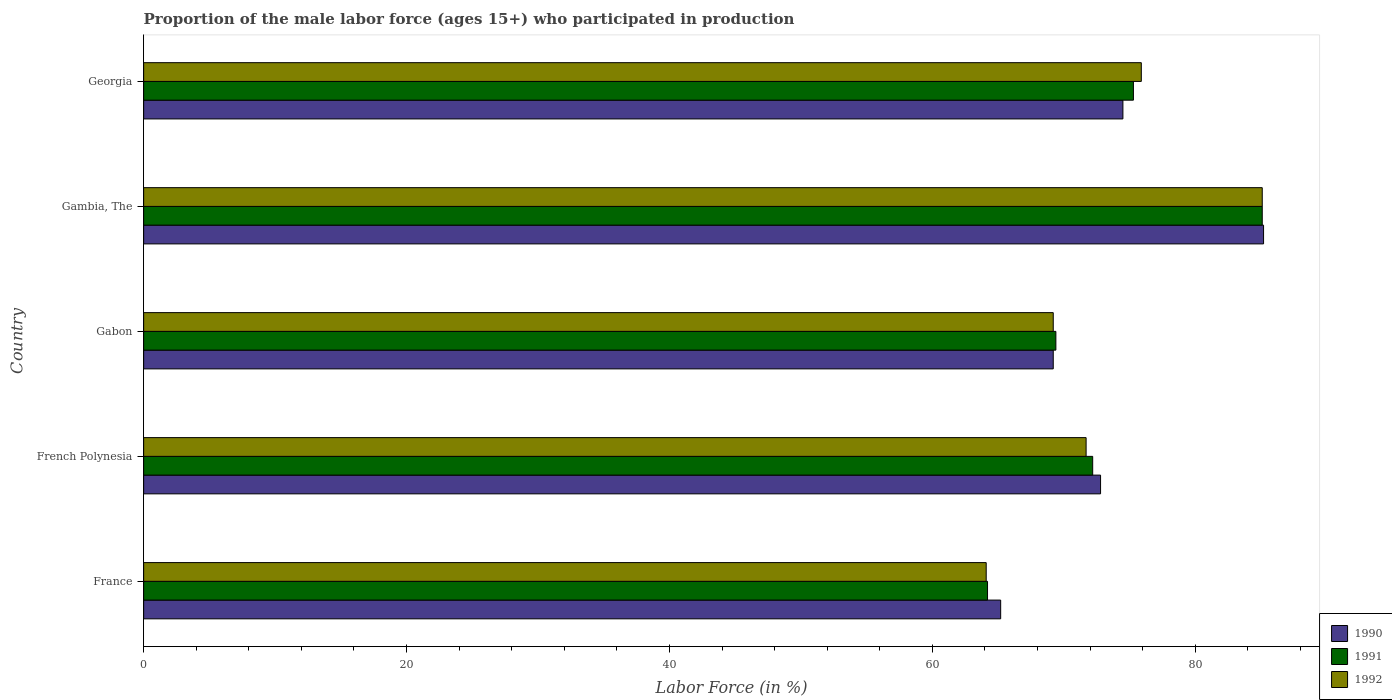Are the number of bars on each tick of the Y-axis equal?
Your answer should be compact. Yes. What is the label of the 5th group of bars from the top?
Offer a terse response. France. What is the proportion of the male labor force who participated in production in 1991 in French Polynesia?
Offer a terse response. 72.2. Across all countries, what is the maximum proportion of the male labor force who participated in production in 1990?
Your response must be concise. 85.2. Across all countries, what is the minimum proportion of the male labor force who participated in production in 1991?
Offer a very short reply. 64.2. In which country was the proportion of the male labor force who participated in production in 1992 maximum?
Provide a succinct answer. Gambia, The. What is the total proportion of the male labor force who participated in production in 1990 in the graph?
Provide a succinct answer. 366.9. What is the difference between the proportion of the male labor force who participated in production in 1992 in Gambia, The and that in Georgia?
Offer a terse response. 9.2. What is the difference between the proportion of the male labor force who participated in production in 1992 in Gambia, The and the proportion of the male labor force who participated in production in 1991 in French Polynesia?
Your answer should be very brief. 12.9. What is the average proportion of the male labor force who participated in production in 1990 per country?
Ensure brevity in your answer.  73.38. What is the difference between the proportion of the male labor force who participated in production in 1992 and proportion of the male labor force who participated in production in 1990 in French Polynesia?
Offer a very short reply. -1.1. What is the ratio of the proportion of the male labor force who participated in production in 1992 in Gambia, The to that in Georgia?
Provide a short and direct response. 1.12. Is the difference between the proportion of the male labor force who participated in production in 1992 in French Polynesia and Gambia, The greater than the difference between the proportion of the male labor force who participated in production in 1990 in French Polynesia and Gambia, The?
Your response must be concise. No. What is the difference between the highest and the second highest proportion of the male labor force who participated in production in 1990?
Offer a terse response. 10.7. What is the difference between the highest and the lowest proportion of the male labor force who participated in production in 1991?
Make the answer very short. 20.9. What does the 3rd bar from the top in Gambia, The represents?
Ensure brevity in your answer.  1990. What does the 1st bar from the bottom in Georgia represents?
Provide a succinct answer. 1990. Are all the bars in the graph horizontal?
Offer a very short reply. Yes. Does the graph contain any zero values?
Offer a very short reply. No. How many legend labels are there?
Provide a succinct answer. 3. What is the title of the graph?
Provide a succinct answer. Proportion of the male labor force (ages 15+) who participated in production. Does "2002" appear as one of the legend labels in the graph?
Offer a terse response. No. What is the label or title of the Y-axis?
Offer a very short reply. Country. What is the Labor Force (in %) of 1990 in France?
Offer a terse response. 65.2. What is the Labor Force (in %) of 1991 in France?
Ensure brevity in your answer.  64.2. What is the Labor Force (in %) of 1992 in France?
Give a very brief answer. 64.1. What is the Labor Force (in %) in 1990 in French Polynesia?
Provide a succinct answer. 72.8. What is the Labor Force (in %) of 1991 in French Polynesia?
Provide a short and direct response. 72.2. What is the Labor Force (in %) of 1992 in French Polynesia?
Provide a succinct answer. 71.7. What is the Labor Force (in %) of 1990 in Gabon?
Your response must be concise. 69.2. What is the Labor Force (in %) in 1991 in Gabon?
Keep it short and to the point. 69.4. What is the Labor Force (in %) of 1992 in Gabon?
Ensure brevity in your answer.  69.2. What is the Labor Force (in %) of 1990 in Gambia, The?
Your answer should be very brief. 85.2. What is the Labor Force (in %) of 1991 in Gambia, The?
Provide a succinct answer. 85.1. What is the Labor Force (in %) in 1992 in Gambia, The?
Keep it short and to the point. 85.1. What is the Labor Force (in %) in 1990 in Georgia?
Provide a succinct answer. 74.5. What is the Labor Force (in %) in 1991 in Georgia?
Offer a very short reply. 75.3. What is the Labor Force (in %) of 1992 in Georgia?
Offer a very short reply. 75.9. Across all countries, what is the maximum Labor Force (in %) in 1990?
Provide a short and direct response. 85.2. Across all countries, what is the maximum Labor Force (in %) of 1991?
Your answer should be very brief. 85.1. Across all countries, what is the maximum Labor Force (in %) of 1992?
Offer a very short reply. 85.1. Across all countries, what is the minimum Labor Force (in %) of 1990?
Your answer should be very brief. 65.2. Across all countries, what is the minimum Labor Force (in %) in 1991?
Your response must be concise. 64.2. Across all countries, what is the minimum Labor Force (in %) of 1992?
Keep it short and to the point. 64.1. What is the total Labor Force (in %) in 1990 in the graph?
Offer a very short reply. 366.9. What is the total Labor Force (in %) of 1991 in the graph?
Your response must be concise. 366.2. What is the total Labor Force (in %) in 1992 in the graph?
Your answer should be very brief. 366. What is the difference between the Labor Force (in %) of 1990 in France and that in French Polynesia?
Offer a very short reply. -7.6. What is the difference between the Labor Force (in %) of 1991 in France and that in French Polynesia?
Give a very brief answer. -8. What is the difference between the Labor Force (in %) of 1992 in France and that in French Polynesia?
Your answer should be compact. -7.6. What is the difference between the Labor Force (in %) in 1991 in France and that in Gabon?
Make the answer very short. -5.2. What is the difference between the Labor Force (in %) of 1991 in France and that in Gambia, The?
Offer a terse response. -20.9. What is the difference between the Labor Force (in %) in 1992 in France and that in Gambia, The?
Your answer should be compact. -21. What is the difference between the Labor Force (in %) in 1990 in France and that in Georgia?
Ensure brevity in your answer.  -9.3. What is the difference between the Labor Force (in %) in 1991 in France and that in Georgia?
Offer a very short reply. -11.1. What is the difference between the Labor Force (in %) in 1991 in French Polynesia and that in Gambia, The?
Give a very brief answer. -12.9. What is the difference between the Labor Force (in %) in 1992 in French Polynesia and that in Gambia, The?
Give a very brief answer. -13.4. What is the difference between the Labor Force (in %) in 1992 in French Polynesia and that in Georgia?
Your answer should be very brief. -4.2. What is the difference between the Labor Force (in %) in 1991 in Gabon and that in Gambia, The?
Your response must be concise. -15.7. What is the difference between the Labor Force (in %) of 1992 in Gabon and that in Gambia, The?
Offer a terse response. -15.9. What is the difference between the Labor Force (in %) of 1991 in Gabon and that in Georgia?
Your answer should be very brief. -5.9. What is the difference between the Labor Force (in %) of 1992 in Gabon and that in Georgia?
Your answer should be compact. -6.7. What is the difference between the Labor Force (in %) of 1990 in Gambia, The and that in Georgia?
Provide a succinct answer. 10.7. What is the difference between the Labor Force (in %) in 1991 in Gambia, The and that in Georgia?
Provide a succinct answer. 9.8. What is the difference between the Labor Force (in %) of 1992 in Gambia, The and that in Georgia?
Your response must be concise. 9.2. What is the difference between the Labor Force (in %) of 1990 in France and the Labor Force (in %) of 1991 in French Polynesia?
Provide a succinct answer. -7. What is the difference between the Labor Force (in %) in 1990 in France and the Labor Force (in %) in 1992 in French Polynesia?
Make the answer very short. -6.5. What is the difference between the Labor Force (in %) of 1990 in France and the Labor Force (in %) of 1992 in Gabon?
Give a very brief answer. -4. What is the difference between the Labor Force (in %) in 1990 in France and the Labor Force (in %) in 1991 in Gambia, The?
Offer a terse response. -19.9. What is the difference between the Labor Force (in %) in 1990 in France and the Labor Force (in %) in 1992 in Gambia, The?
Your response must be concise. -19.9. What is the difference between the Labor Force (in %) in 1991 in France and the Labor Force (in %) in 1992 in Gambia, The?
Your response must be concise. -20.9. What is the difference between the Labor Force (in %) of 1990 in France and the Labor Force (in %) of 1992 in Georgia?
Give a very brief answer. -10.7. What is the difference between the Labor Force (in %) in 1991 in France and the Labor Force (in %) in 1992 in Georgia?
Your response must be concise. -11.7. What is the difference between the Labor Force (in %) of 1990 in French Polynesia and the Labor Force (in %) of 1991 in Gabon?
Your answer should be very brief. 3.4. What is the difference between the Labor Force (in %) in 1991 in French Polynesia and the Labor Force (in %) in 1992 in Gambia, The?
Provide a succinct answer. -12.9. What is the difference between the Labor Force (in %) of 1990 in French Polynesia and the Labor Force (in %) of 1991 in Georgia?
Provide a short and direct response. -2.5. What is the difference between the Labor Force (in %) in 1990 in French Polynesia and the Labor Force (in %) in 1992 in Georgia?
Offer a very short reply. -3.1. What is the difference between the Labor Force (in %) in 1991 in French Polynesia and the Labor Force (in %) in 1992 in Georgia?
Provide a short and direct response. -3.7. What is the difference between the Labor Force (in %) in 1990 in Gabon and the Labor Force (in %) in 1991 in Gambia, The?
Your answer should be compact. -15.9. What is the difference between the Labor Force (in %) of 1990 in Gabon and the Labor Force (in %) of 1992 in Gambia, The?
Offer a very short reply. -15.9. What is the difference between the Labor Force (in %) of 1991 in Gabon and the Labor Force (in %) of 1992 in Gambia, The?
Offer a terse response. -15.7. What is the difference between the Labor Force (in %) of 1991 in Gabon and the Labor Force (in %) of 1992 in Georgia?
Provide a short and direct response. -6.5. What is the difference between the Labor Force (in %) of 1990 in Gambia, The and the Labor Force (in %) of 1992 in Georgia?
Keep it short and to the point. 9.3. What is the difference between the Labor Force (in %) in 1991 in Gambia, The and the Labor Force (in %) in 1992 in Georgia?
Your response must be concise. 9.2. What is the average Labor Force (in %) of 1990 per country?
Give a very brief answer. 73.38. What is the average Labor Force (in %) in 1991 per country?
Provide a short and direct response. 73.24. What is the average Labor Force (in %) of 1992 per country?
Your answer should be compact. 73.2. What is the difference between the Labor Force (in %) of 1990 and Labor Force (in %) of 1991 in France?
Your response must be concise. 1. What is the difference between the Labor Force (in %) of 1990 and Labor Force (in %) of 1992 in France?
Make the answer very short. 1.1. What is the difference between the Labor Force (in %) of 1990 and Labor Force (in %) of 1991 in French Polynesia?
Make the answer very short. 0.6. What is the difference between the Labor Force (in %) of 1991 and Labor Force (in %) of 1992 in French Polynesia?
Provide a short and direct response. 0.5. What is the difference between the Labor Force (in %) of 1990 and Labor Force (in %) of 1992 in Gabon?
Provide a short and direct response. 0. What is the difference between the Labor Force (in %) in 1990 and Labor Force (in %) in 1991 in Gambia, The?
Offer a terse response. 0.1. What is the difference between the Labor Force (in %) in 1990 and Labor Force (in %) in 1992 in Gambia, The?
Provide a succinct answer. 0.1. What is the difference between the Labor Force (in %) in 1990 and Labor Force (in %) in 1991 in Georgia?
Make the answer very short. -0.8. What is the ratio of the Labor Force (in %) of 1990 in France to that in French Polynesia?
Offer a terse response. 0.9. What is the ratio of the Labor Force (in %) of 1991 in France to that in French Polynesia?
Ensure brevity in your answer.  0.89. What is the ratio of the Labor Force (in %) in 1992 in France to that in French Polynesia?
Keep it short and to the point. 0.89. What is the ratio of the Labor Force (in %) of 1990 in France to that in Gabon?
Provide a short and direct response. 0.94. What is the ratio of the Labor Force (in %) of 1991 in France to that in Gabon?
Make the answer very short. 0.93. What is the ratio of the Labor Force (in %) of 1992 in France to that in Gabon?
Provide a short and direct response. 0.93. What is the ratio of the Labor Force (in %) in 1990 in France to that in Gambia, The?
Provide a short and direct response. 0.77. What is the ratio of the Labor Force (in %) in 1991 in France to that in Gambia, The?
Provide a succinct answer. 0.75. What is the ratio of the Labor Force (in %) in 1992 in France to that in Gambia, The?
Your response must be concise. 0.75. What is the ratio of the Labor Force (in %) in 1990 in France to that in Georgia?
Make the answer very short. 0.88. What is the ratio of the Labor Force (in %) in 1991 in France to that in Georgia?
Offer a terse response. 0.85. What is the ratio of the Labor Force (in %) in 1992 in France to that in Georgia?
Provide a short and direct response. 0.84. What is the ratio of the Labor Force (in %) of 1990 in French Polynesia to that in Gabon?
Offer a very short reply. 1.05. What is the ratio of the Labor Force (in %) of 1991 in French Polynesia to that in Gabon?
Your answer should be compact. 1.04. What is the ratio of the Labor Force (in %) of 1992 in French Polynesia to that in Gabon?
Your answer should be very brief. 1.04. What is the ratio of the Labor Force (in %) in 1990 in French Polynesia to that in Gambia, The?
Ensure brevity in your answer.  0.85. What is the ratio of the Labor Force (in %) of 1991 in French Polynesia to that in Gambia, The?
Your response must be concise. 0.85. What is the ratio of the Labor Force (in %) of 1992 in French Polynesia to that in Gambia, The?
Provide a succinct answer. 0.84. What is the ratio of the Labor Force (in %) of 1990 in French Polynesia to that in Georgia?
Give a very brief answer. 0.98. What is the ratio of the Labor Force (in %) in 1991 in French Polynesia to that in Georgia?
Provide a succinct answer. 0.96. What is the ratio of the Labor Force (in %) in 1992 in French Polynesia to that in Georgia?
Your response must be concise. 0.94. What is the ratio of the Labor Force (in %) of 1990 in Gabon to that in Gambia, The?
Provide a short and direct response. 0.81. What is the ratio of the Labor Force (in %) in 1991 in Gabon to that in Gambia, The?
Make the answer very short. 0.82. What is the ratio of the Labor Force (in %) of 1992 in Gabon to that in Gambia, The?
Give a very brief answer. 0.81. What is the ratio of the Labor Force (in %) in 1990 in Gabon to that in Georgia?
Make the answer very short. 0.93. What is the ratio of the Labor Force (in %) in 1991 in Gabon to that in Georgia?
Keep it short and to the point. 0.92. What is the ratio of the Labor Force (in %) in 1992 in Gabon to that in Georgia?
Keep it short and to the point. 0.91. What is the ratio of the Labor Force (in %) of 1990 in Gambia, The to that in Georgia?
Your response must be concise. 1.14. What is the ratio of the Labor Force (in %) of 1991 in Gambia, The to that in Georgia?
Keep it short and to the point. 1.13. What is the ratio of the Labor Force (in %) in 1992 in Gambia, The to that in Georgia?
Your answer should be compact. 1.12. What is the difference between the highest and the lowest Labor Force (in %) of 1990?
Ensure brevity in your answer.  20. What is the difference between the highest and the lowest Labor Force (in %) of 1991?
Your answer should be compact. 20.9. What is the difference between the highest and the lowest Labor Force (in %) in 1992?
Give a very brief answer. 21. 